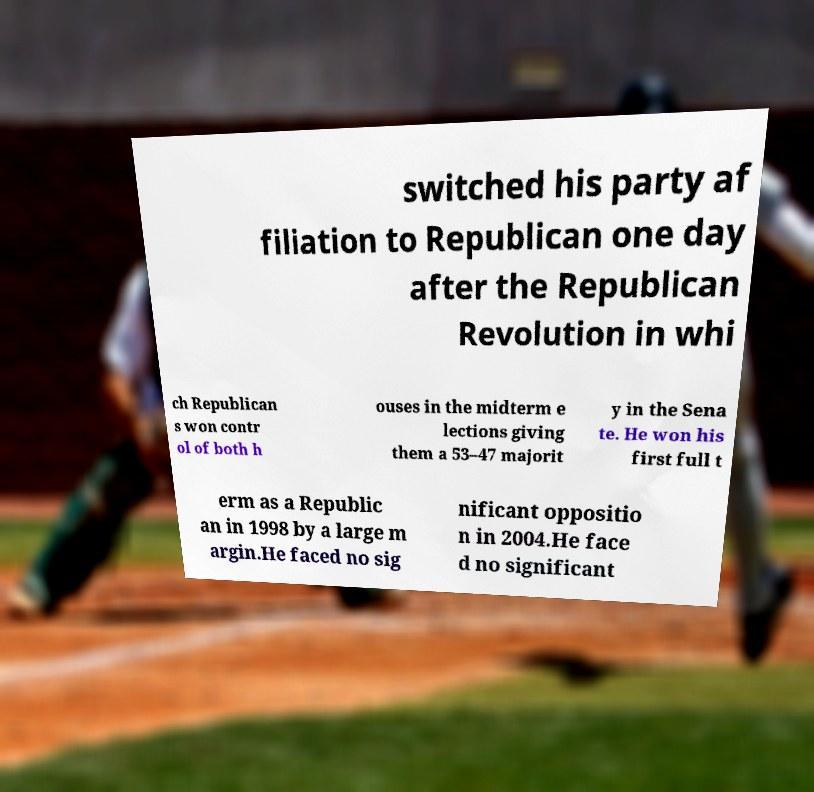For documentation purposes, I need the text within this image transcribed. Could you provide that? switched his party af filiation to Republican one day after the Republican Revolution in whi ch Republican s won contr ol of both h ouses in the midterm e lections giving them a 53–47 majorit y in the Sena te. He won his first full t erm as a Republic an in 1998 by a large m argin.He faced no sig nificant oppositio n in 2004.He face d no significant 